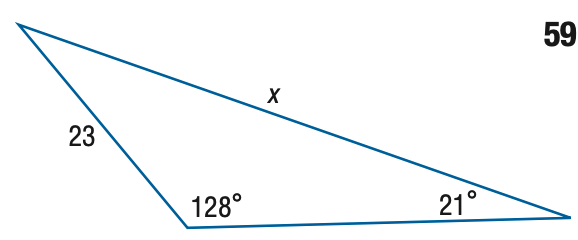Answer the mathemtical geometry problem and directly provide the correct option letter.
Question: Find x. Round the side measure to the nearest tenth.
Choices: A: 10.5 B: 15.0 C: 35.2 D: 50.6 D 